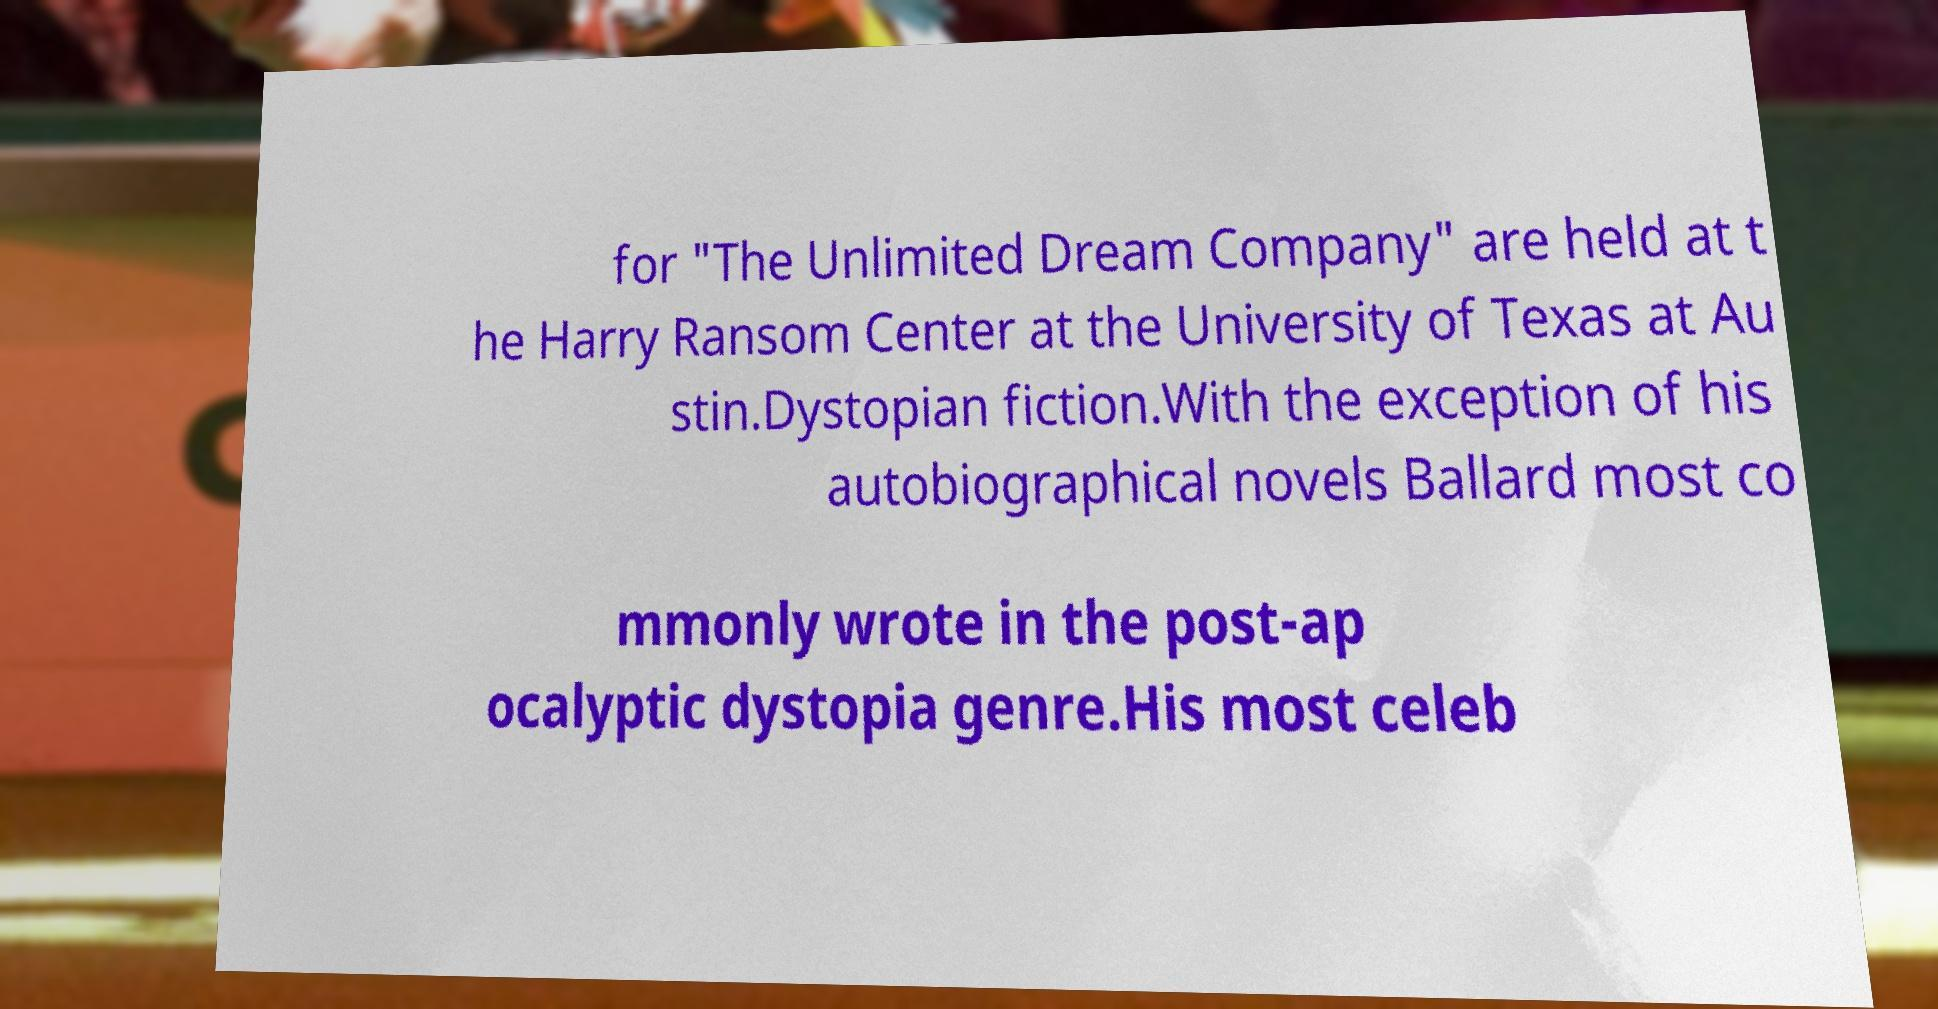Please read and relay the text visible in this image. What does it say? for "The Unlimited Dream Company" are held at t he Harry Ransom Center at the University of Texas at Au stin.Dystopian fiction.With the exception of his autobiographical novels Ballard most co mmonly wrote in the post-ap ocalyptic dystopia genre.His most celeb 